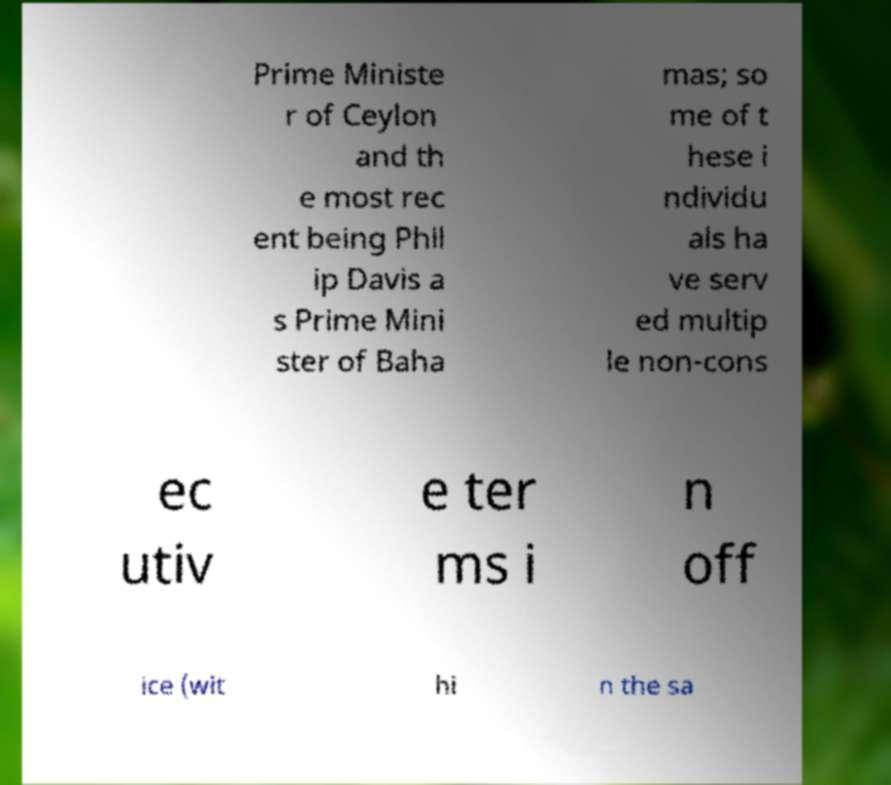Can you accurately transcribe the text from the provided image for me? Prime Ministe r of Ceylon and th e most rec ent being Phil ip Davis a s Prime Mini ster of Baha mas; so me of t hese i ndividu als ha ve serv ed multip le non-cons ec utiv e ter ms i n off ice (wit hi n the sa 